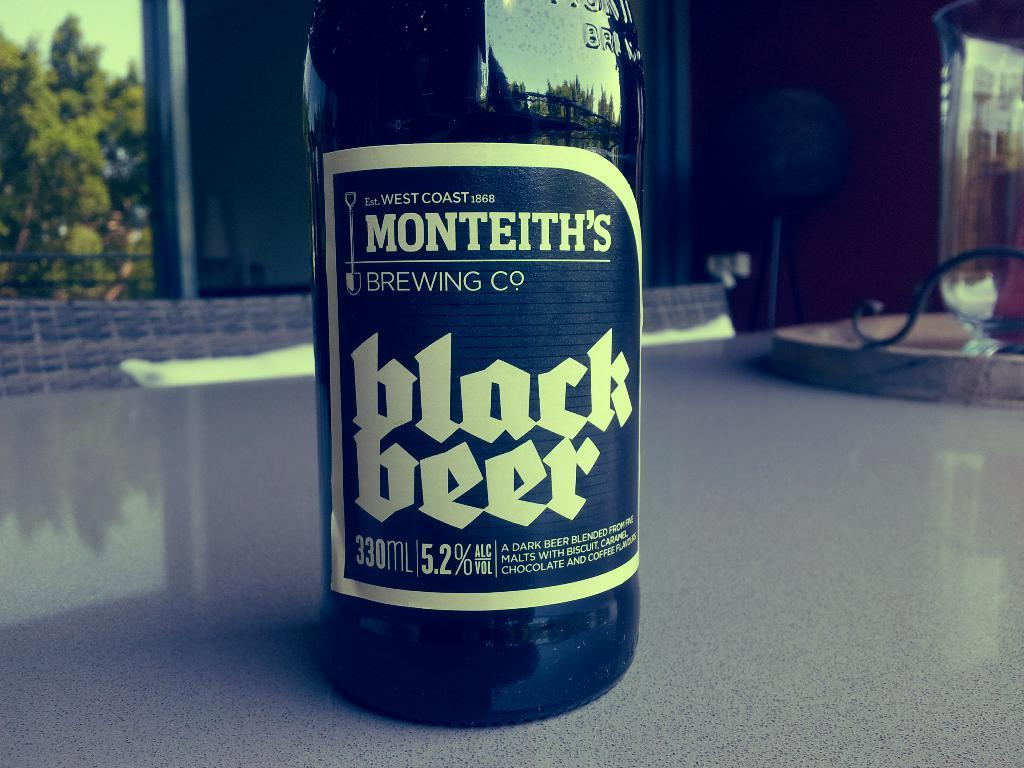Provide a one-sentence caption for the provided image. A close up of a bottle of Monteith's Black Beer. 